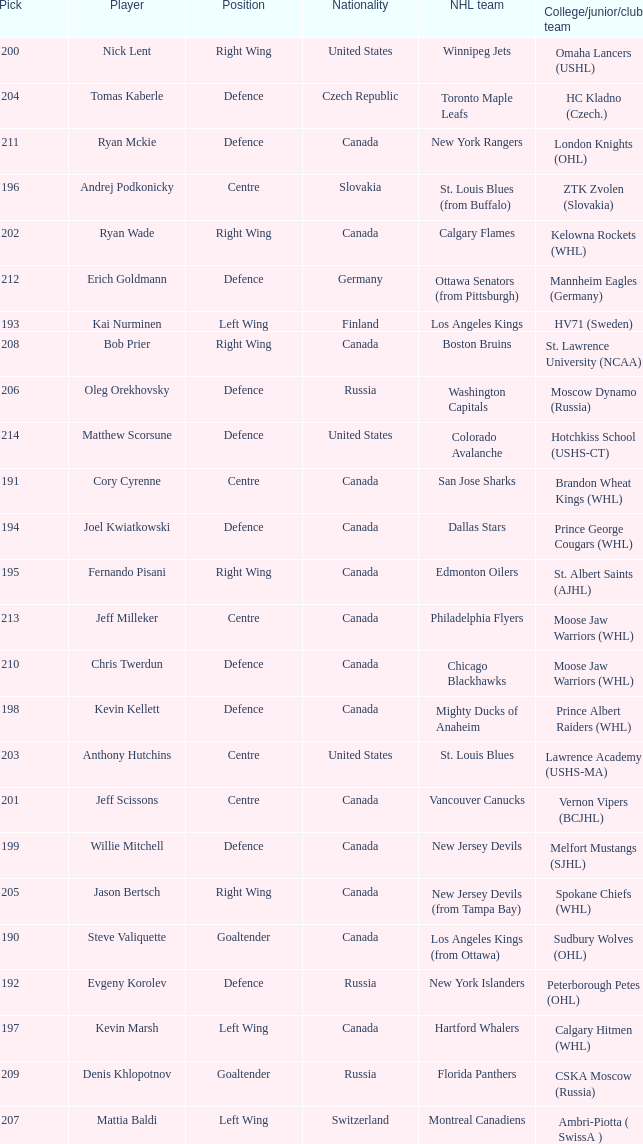Name the most pick for evgeny korolev 192.0. 